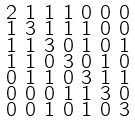Convert formula to latex. <formula><loc_0><loc_0><loc_500><loc_500>\begin{smallmatrix} 2 & 1 & 1 & 1 & 0 & 0 & 0 \\ 1 & 3 & 1 & 1 & 1 & 0 & 0 \\ 1 & 1 & 3 & 0 & 1 & 0 & 1 \\ 1 & 1 & 0 & 3 & 0 & 1 & 0 \\ 0 & 1 & 1 & 0 & 3 & 1 & 1 \\ 0 & 0 & 0 & 1 & 1 & 3 & 0 \\ 0 & 0 & 1 & 0 & 1 & 0 & 3 \end{smallmatrix}</formula> 